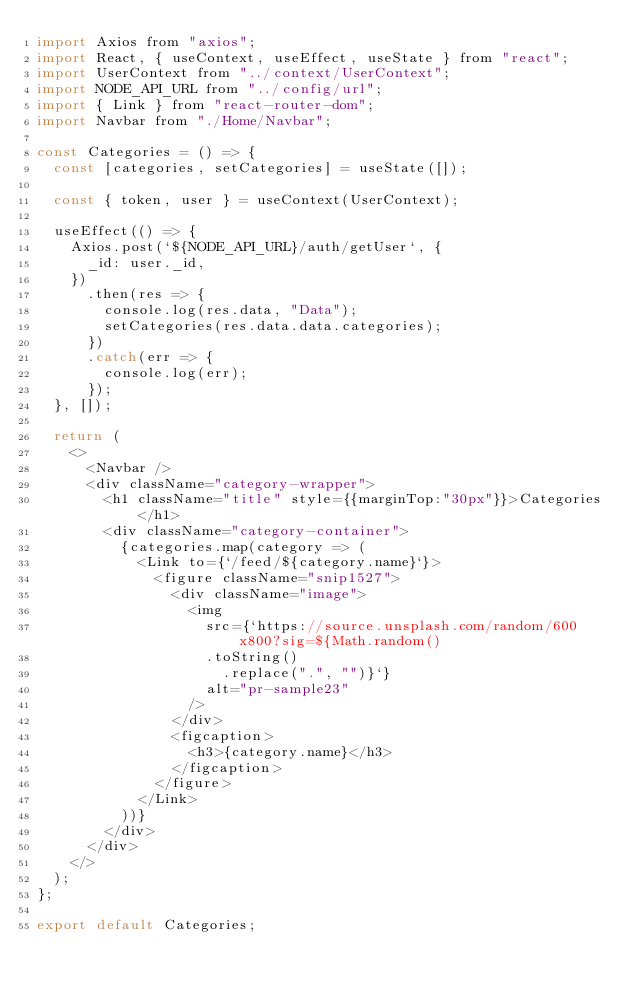Convert code to text. <code><loc_0><loc_0><loc_500><loc_500><_JavaScript_>import Axios from "axios";
import React, { useContext, useEffect, useState } from "react";
import UserContext from "../context/UserContext";
import NODE_API_URL from "../config/url";
import { Link } from "react-router-dom";
import Navbar from "./Home/Navbar";

const Categories = () => {
	const [categories, setCategories] = useState([]);

	const { token, user } = useContext(UserContext);

	useEffect(() => {
		Axios.post(`${NODE_API_URL}/auth/getUser`, {
			_id: user._id,
		})
			.then(res => {
				console.log(res.data, "Data");
				setCategories(res.data.data.categories);
			})
			.catch(err => {
				console.log(err);
			});
	}, []);

	return (
		<>
			<Navbar />
			<div className="category-wrapper">
				<h1 className="title" style={{marginTop:"30px"}}>Categories</h1>
				<div className="category-container">
					{categories.map(category => (
						<Link to={`/feed/${category.name}`}>
							<figure className="snip1527">
								<div className="image">
									<img
										src={`https://source.unsplash.com/random/600x800?sig=${Math.random()
										.toString()
											.replace(".", "")}`}
										alt="pr-sample23"
									/>
								</div>
								<figcaption>
									<h3>{category.name}</h3>
								</figcaption>
							</figure>
						</Link>
					))}
				</div>
			</div>
		</>
	);
};

export default Categories;
</code> 